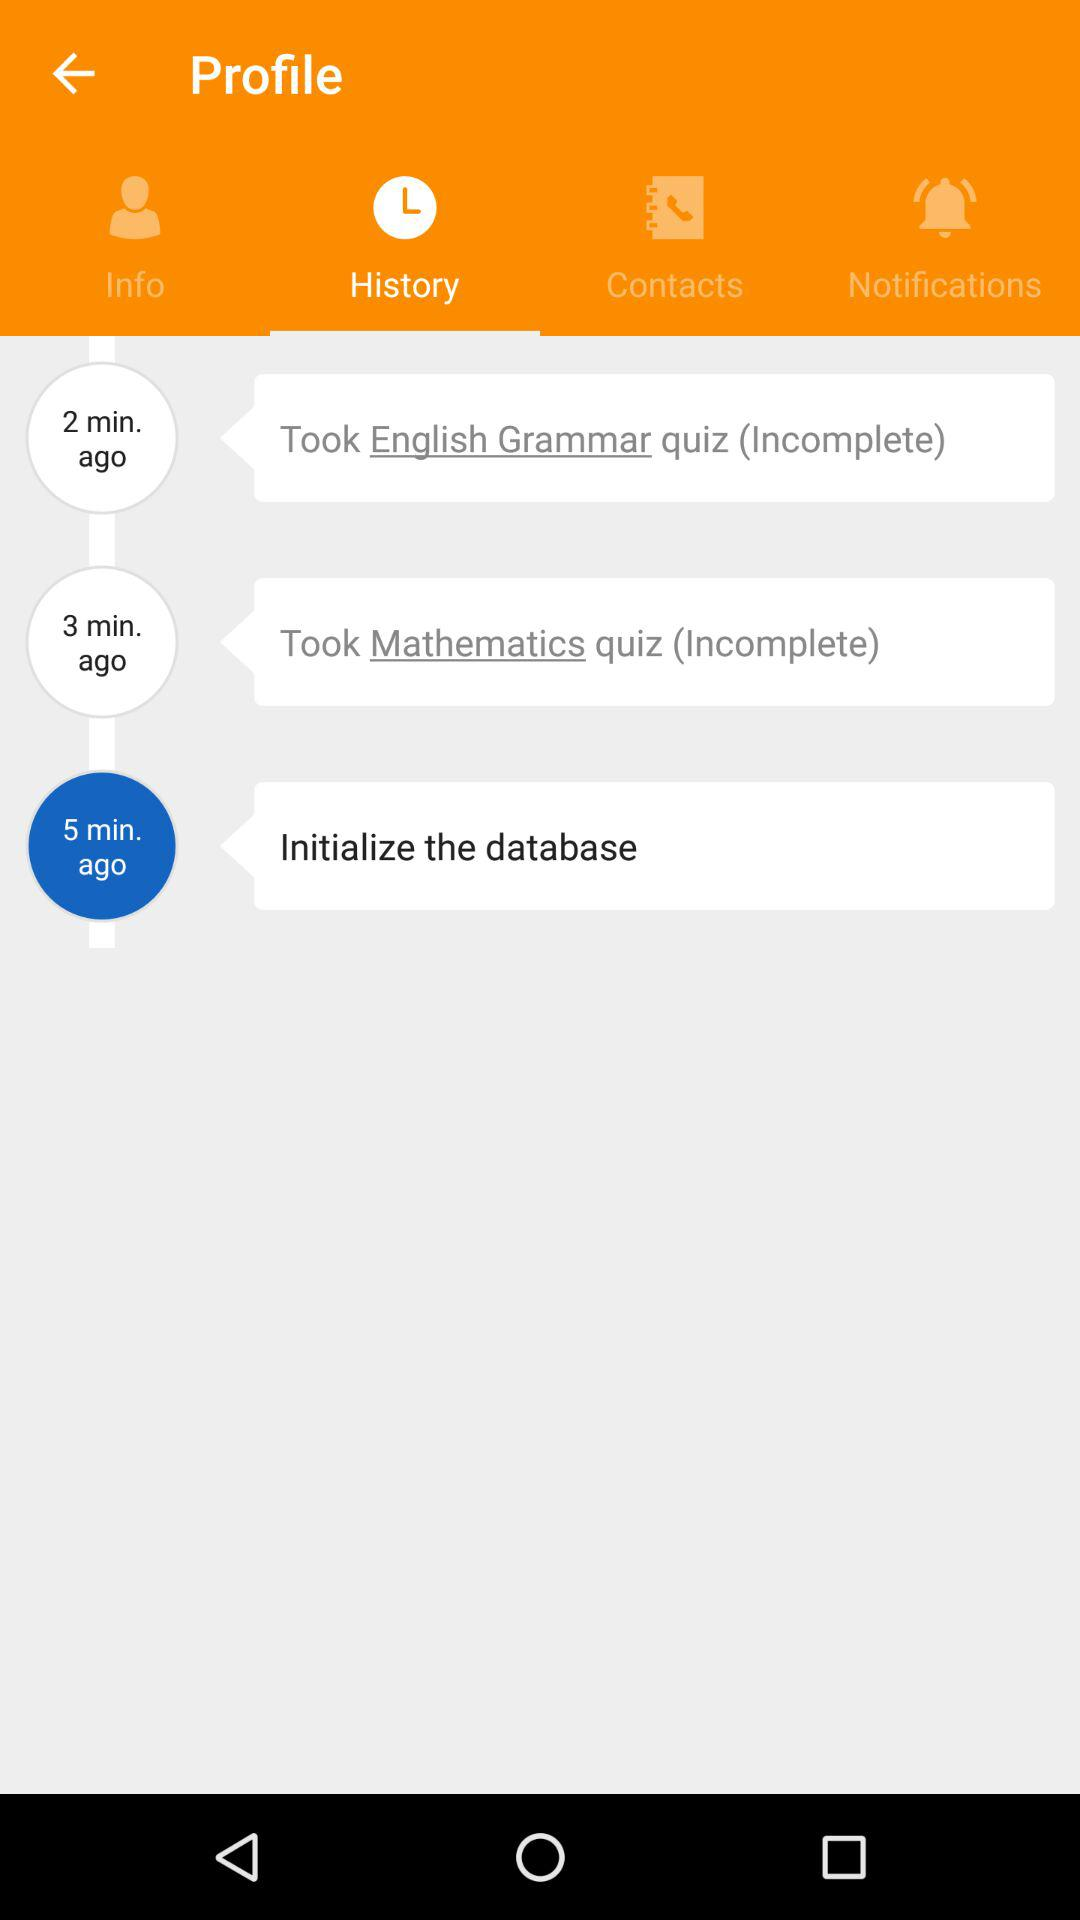How long ago was the database initialized? The database was initialized 5 minutes ago. 